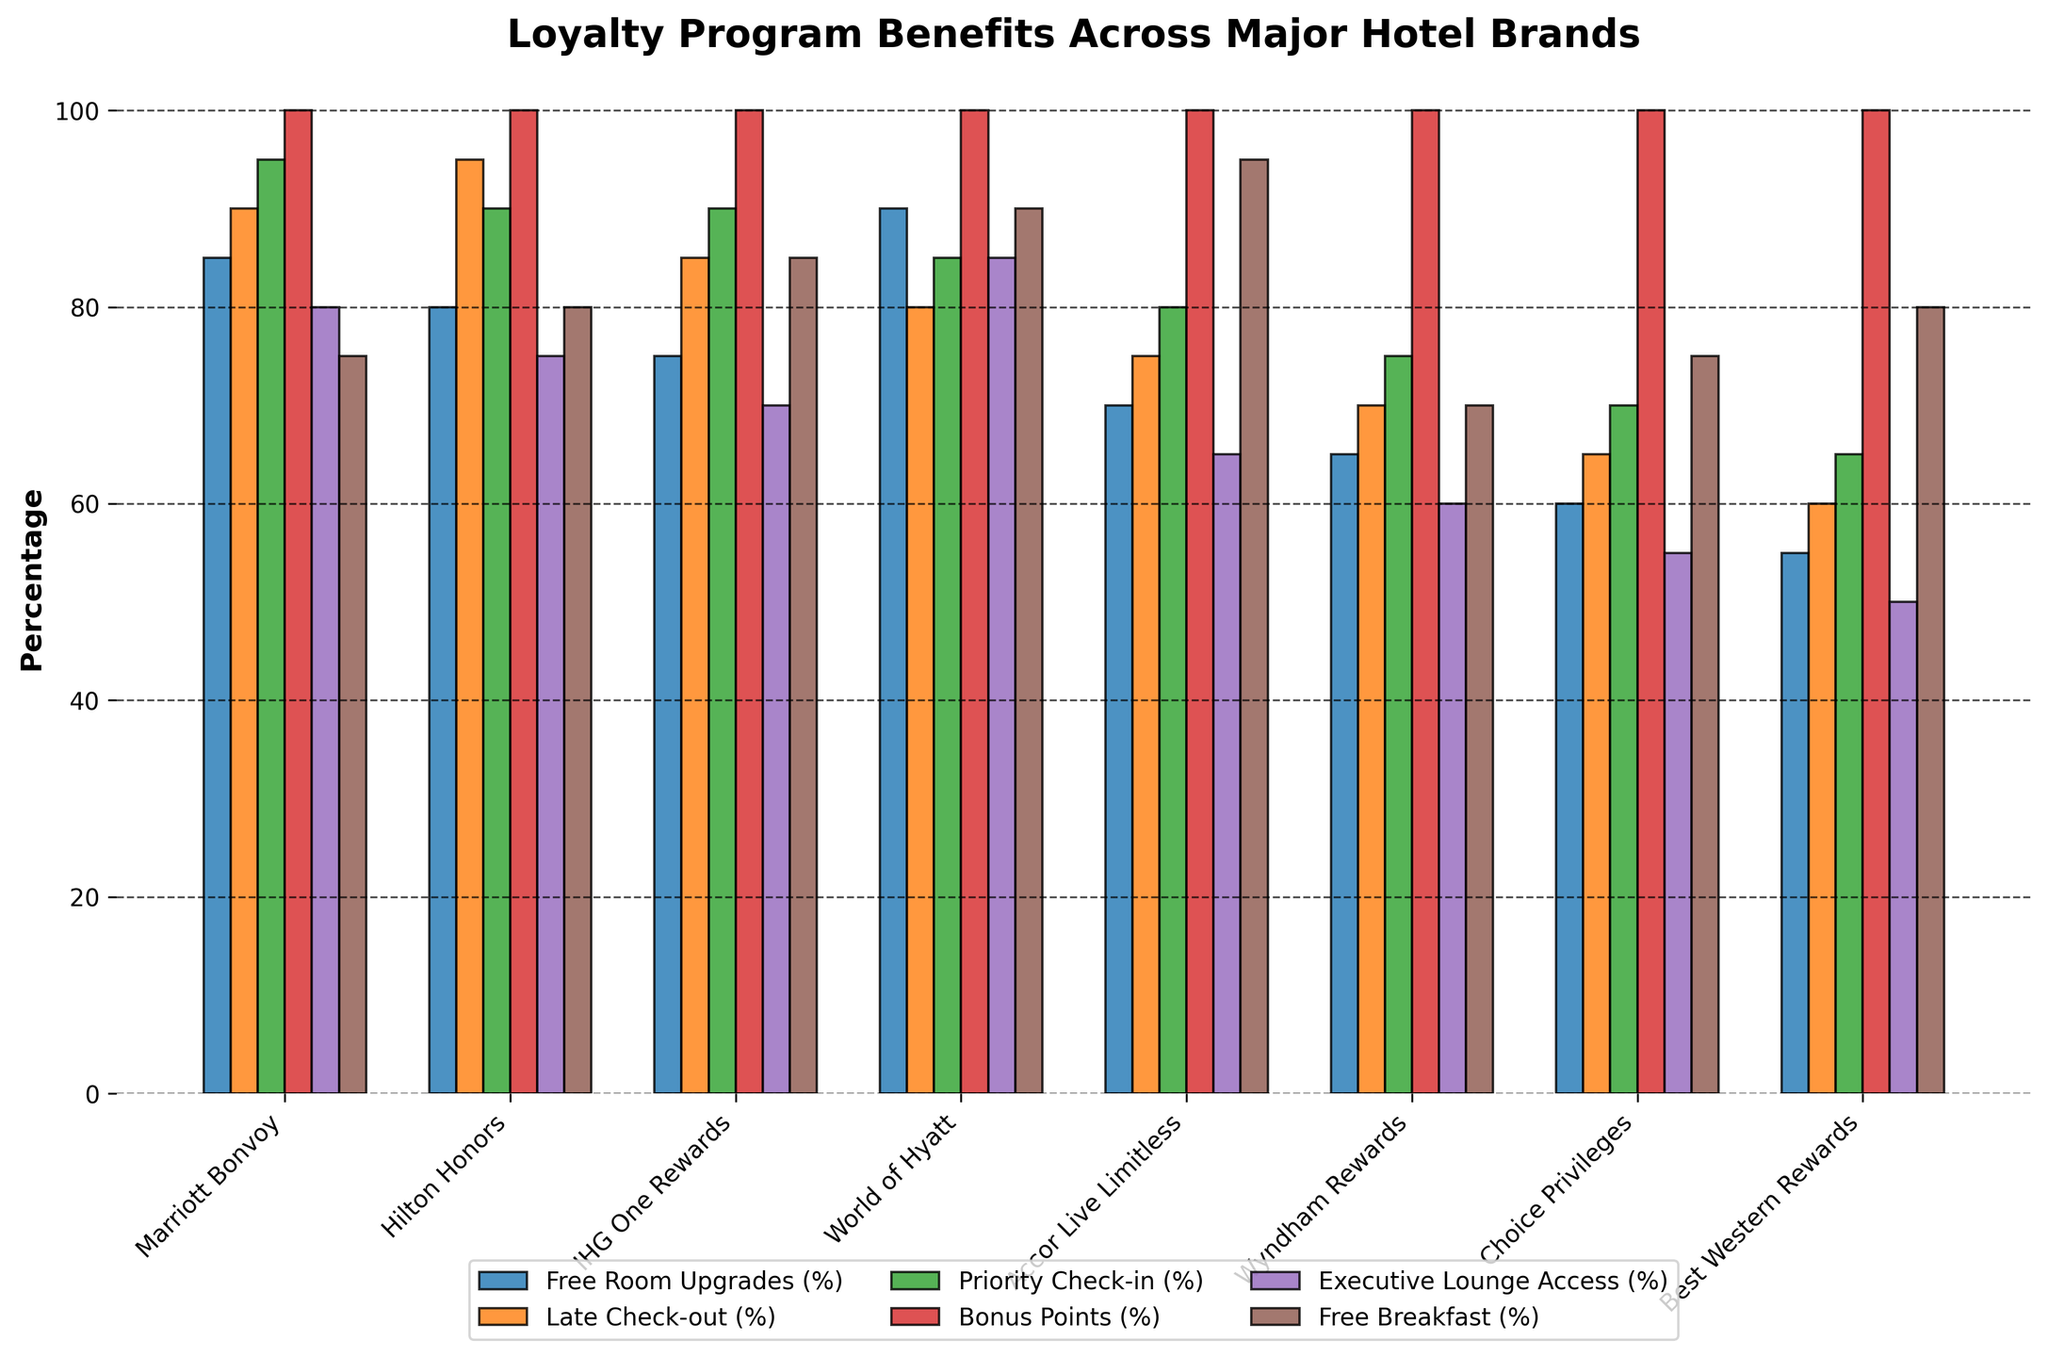Which hotel chain offers the highest percentage for free breakfast? By examining the heights of the bars for the free breakfast category across the hotel chains, the tallest bar corresponds to Accor Live Limitless with 95%.
Answer: Accor Live Limitless Among Marriott Bonvoy, Hilton Honors, and IHG One Rewards, which chain provides the highest percentage for late check-out? The bars for late check-out for Marriott Bonvoy, Hilton Honors, and IHG One Rewards can be visually compared, with Hilton Honors having the tallest bar at 95%.
Answer: Hilton Honors What is the difference in the percentage of free room upgrades between World of Hyatt and Wyndham Rewards? By locating the free room upgrades category and comparing the bars for World of Hyatt (90%) and Wyndham Rewards (65%), the difference can be calculated as 90 - 65 = 25.
Answer: 25 What is the average percentage of priority check-in benefits provided by all hotel chains? Summing the percentages for priority check-in across all hotel chains (95 + 90 + 90 + 85 + 80 + 75 + 70 + 65) equals 650. Dividing by the number of hotel chains (8), the average is 650 / 8 = 81.25.
Answer: 81.25 Which benefit is offered at exactly the same percentage by all hotel chains, and what is that percentage? By examining the height of the bars across all categories, bonus points is the only benefit offered at the same percentage (100%) across all hotel chains.
Answer: Bonus Points, 100% For Choice Privileges, which benefit has the lowest percentage, and what is that percentage? For Choice Privileges, visually comparing the heights of the bars, the lowest bar corresponds to executive lounge access with 55%.
Answer: Executive Lounge Access, 55% How much higher is the percentage for free breakfast in World of Hyatt compared to Wyndham Rewards? By examining the bar heights for the free breakfast category, World of Hyatt offers 90% while Wyndham Rewards offers 70%. The difference is 90 - 70 = 20.
Answer: 20 Across all hotel chains, which two benefits have the most varied percentages? By comparing the variance in bar heights, free room upgrades and executive lounge access show the most variation, with a range of 30% (90 - 60) and 35% (85 - 50) respectively.
Answer: Free Room Upgrades and Executive Lounge Access 